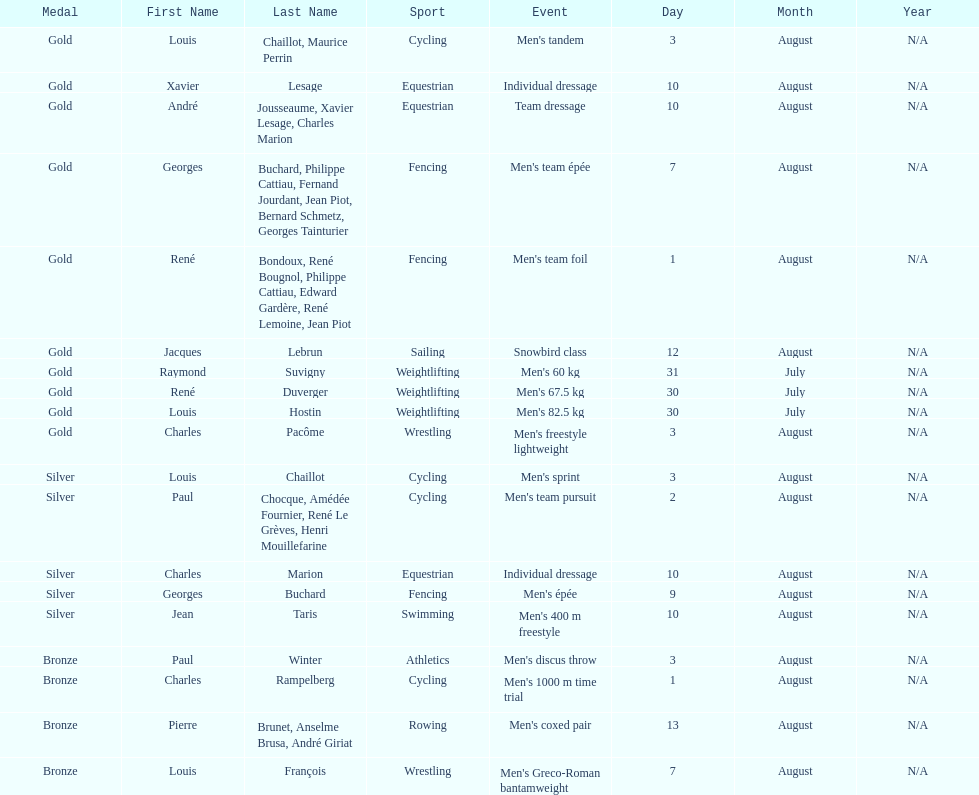What sport is listed first? Cycling. 